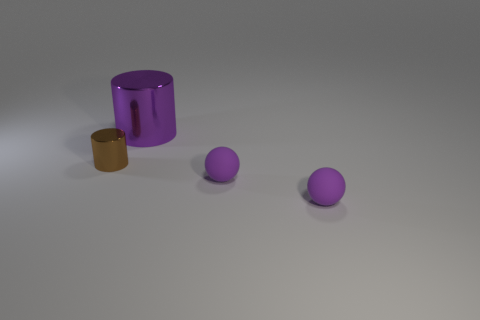Add 3 brown metal cylinders. How many objects exist? 7 Subtract all big things. Subtract all tiny purple things. How many objects are left? 1 Add 4 purple things. How many purple things are left? 7 Add 4 tiny rubber objects. How many tiny rubber objects exist? 6 Subtract all brown cylinders. How many cylinders are left? 1 Subtract 1 purple cylinders. How many objects are left? 3 Subtract 2 cylinders. How many cylinders are left? 0 Subtract all purple cylinders. Subtract all blue blocks. How many cylinders are left? 1 Subtract all green blocks. How many blue spheres are left? 0 